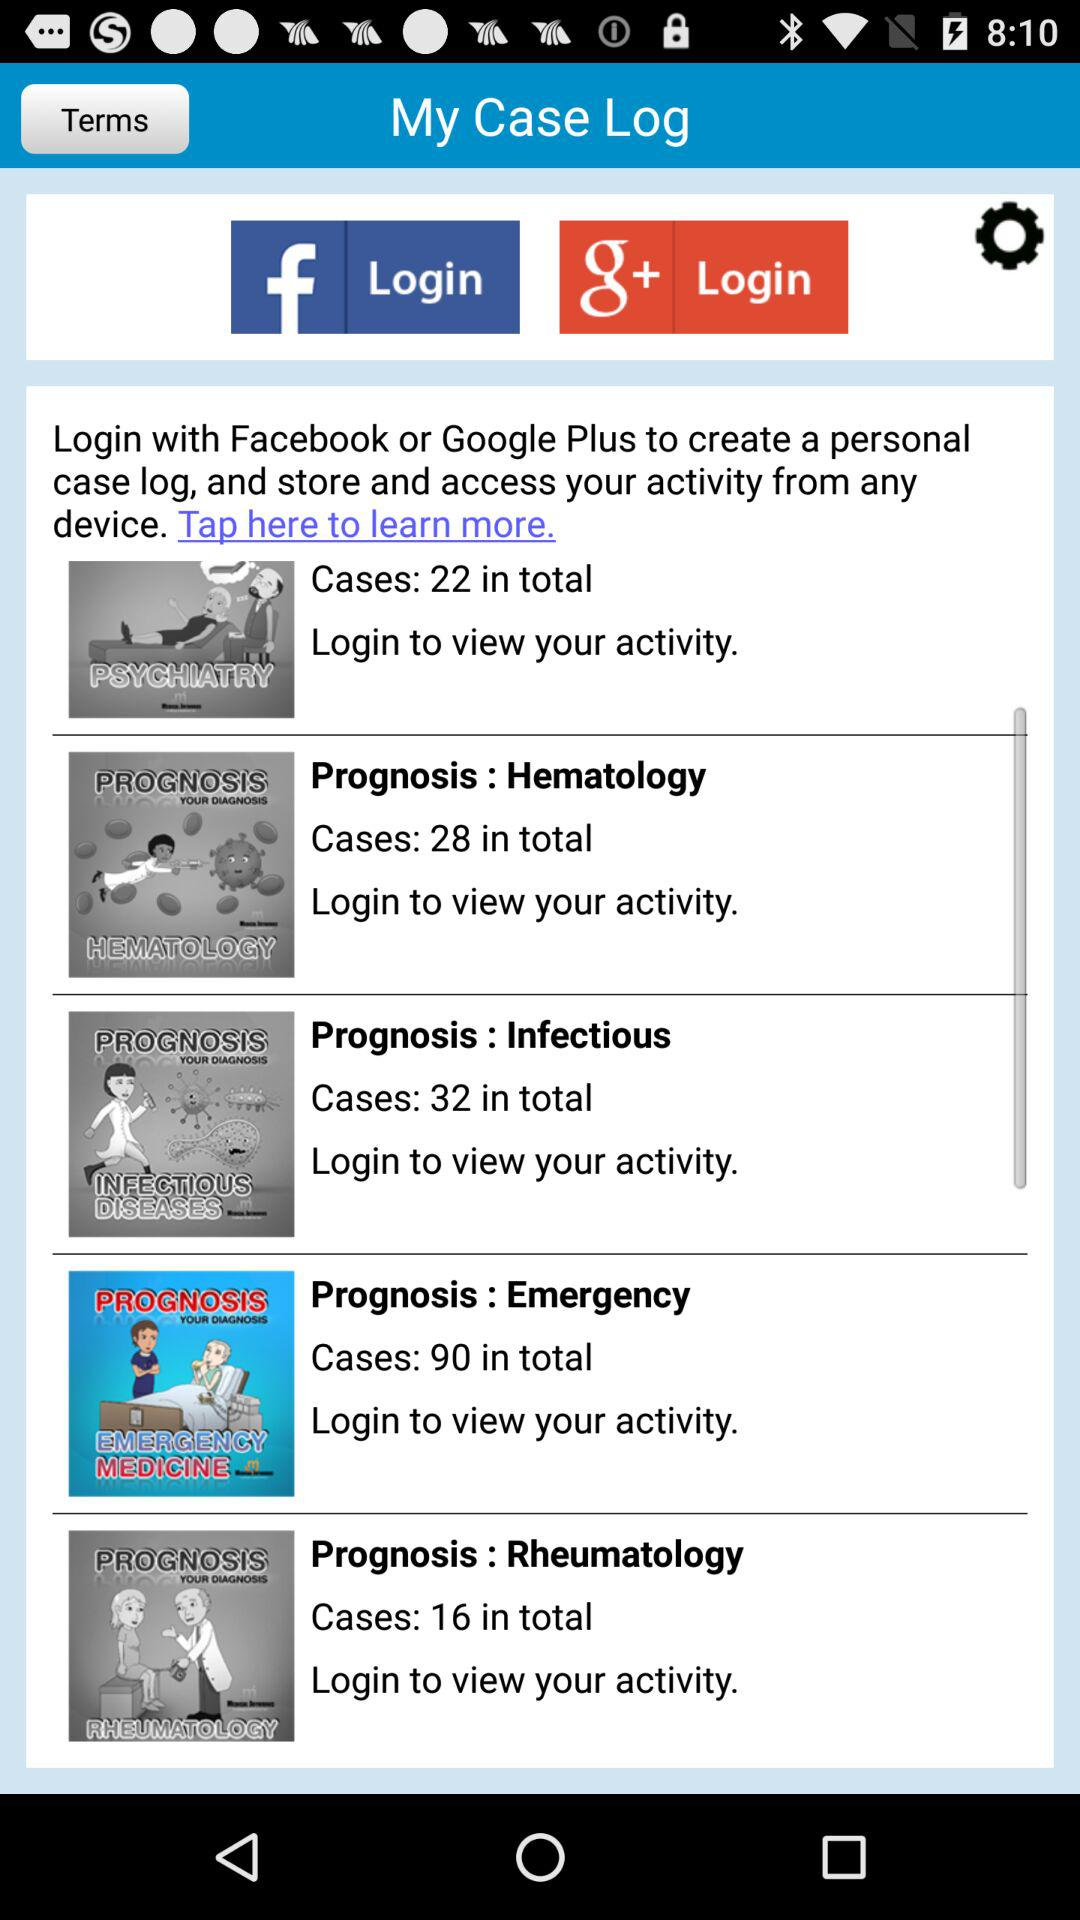How many cases are there in total for the prognosis Rheumatology?
Answer the question using a single word or phrase. 16 